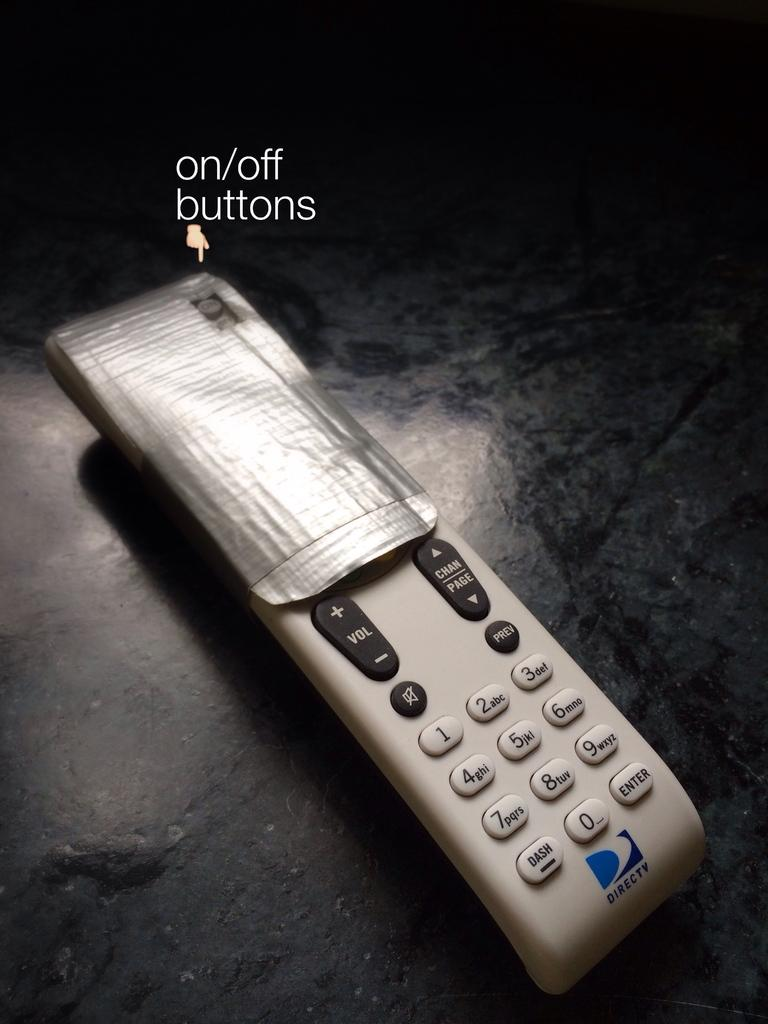<image>
Create a compact narrative representing the image presented. A DirecTV remote half covered with duct tape 